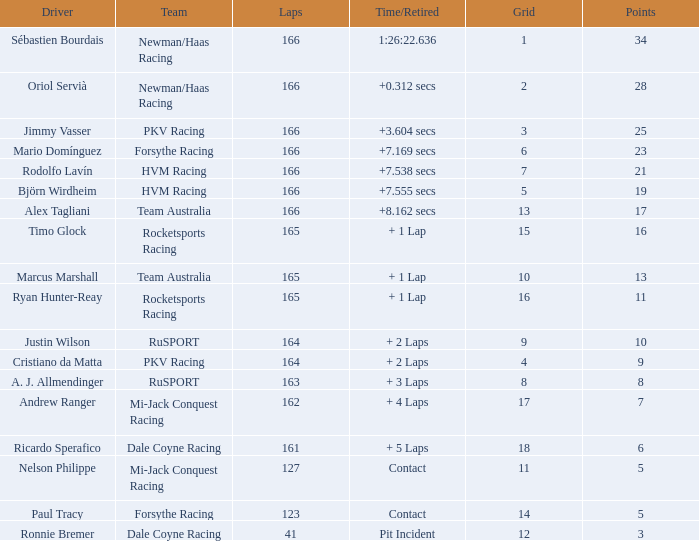What is the name of the motorist with 6 points? Ricardo Sperafico. 